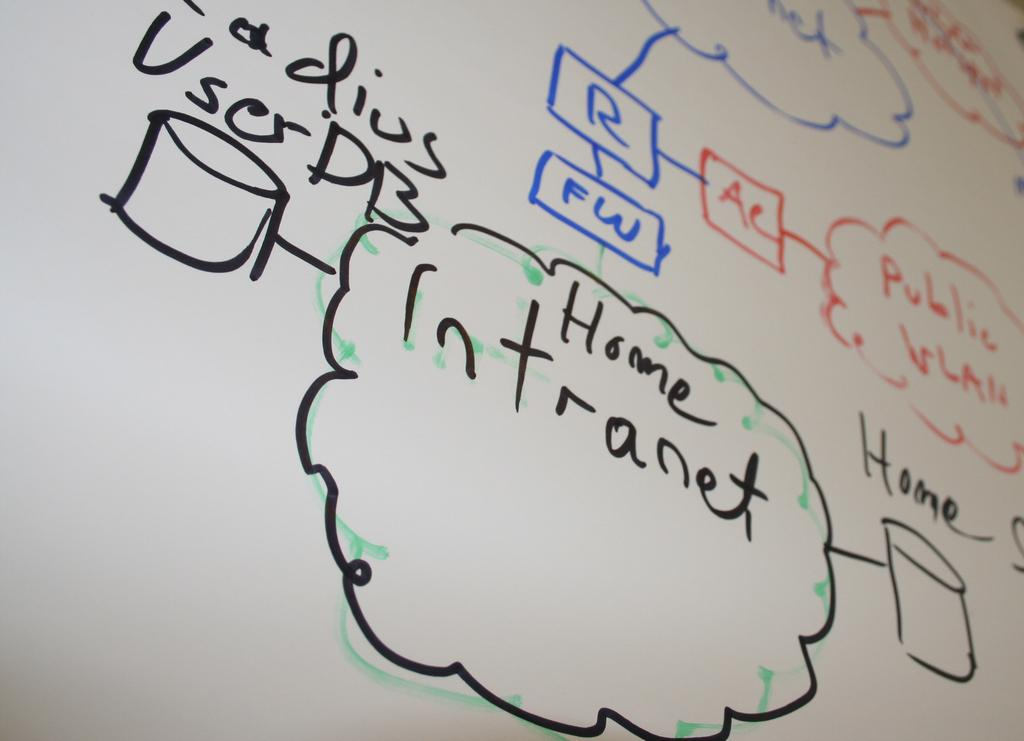<image>
Relay a brief, clear account of the picture shown. White board with flow chart showing a user's internet activity, including Home Intranet and Radius User DB as part of chart. 